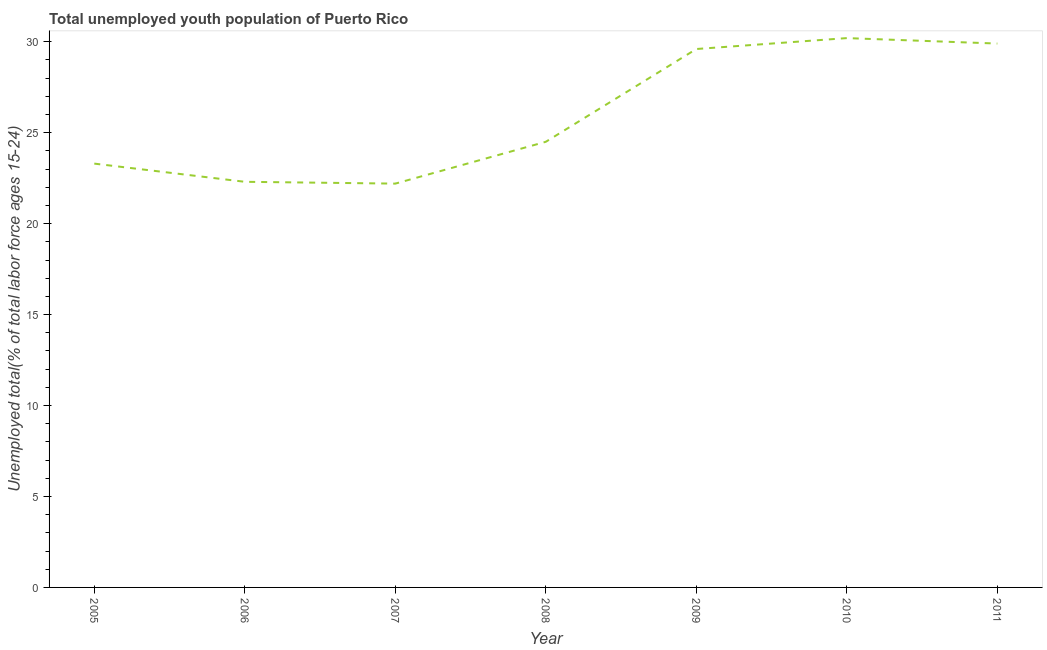What is the unemployed youth in 2005?
Give a very brief answer. 23.3. Across all years, what is the maximum unemployed youth?
Your answer should be very brief. 30.2. Across all years, what is the minimum unemployed youth?
Keep it short and to the point. 22.2. In which year was the unemployed youth maximum?
Ensure brevity in your answer.  2010. In which year was the unemployed youth minimum?
Ensure brevity in your answer.  2007. What is the sum of the unemployed youth?
Your response must be concise. 182. What is the difference between the unemployed youth in 2005 and 2010?
Give a very brief answer. -6.9. What is the average unemployed youth per year?
Make the answer very short. 26. What is the median unemployed youth?
Provide a succinct answer. 24.5. Do a majority of the years between 2009 and 2008 (inclusive) have unemployed youth greater than 6 %?
Give a very brief answer. No. What is the ratio of the unemployed youth in 2005 to that in 2009?
Ensure brevity in your answer.  0.79. What is the difference between the highest and the second highest unemployed youth?
Your answer should be compact. 0.3. Is the sum of the unemployed youth in 2007 and 2011 greater than the maximum unemployed youth across all years?
Offer a terse response. Yes. In how many years, is the unemployed youth greater than the average unemployed youth taken over all years?
Offer a terse response. 3. Does the unemployed youth monotonically increase over the years?
Offer a terse response. No. How many lines are there?
Your answer should be very brief. 1. What is the difference between two consecutive major ticks on the Y-axis?
Your answer should be very brief. 5. Does the graph contain any zero values?
Provide a short and direct response. No. Does the graph contain grids?
Keep it short and to the point. No. What is the title of the graph?
Offer a very short reply. Total unemployed youth population of Puerto Rico. What is the label or title of the X-axis?
Ensure brevity in your answer.  Year. What is the label or title of the Y-axis?
Provide a short and direct response. Unemployed total(% of total labor force ages 15-24). What is the Unemployed total(% of total labor force ages 15-24) in 2005?
Keep it short and to the point. 23.3. What is the Unemployed total(% of total labor force ages 15-24) in 2006?
Provide a short and direct response. 22.3. What is the Unemployed total(% of total labor force ages 15-24) in 2007?
Keep it short and to the point. 22.2. What is the Unemployed total(% of total labor force ages 15-24) of 2009?
Offer a very short reply. 29.6. What is the Unemployed total(% of total labor force ages 15-24) in 2010?
Offer a terse response. 30.2. What is the Unemployed total(% of total labor force ages 15-24) of 2011?
Your response must be concise. 29.9. What is the difference between the Unemployed total(% of total labor force ages 15-24) in 2005 and 2006?
Your answer should be compact. 1. What is the difference between the Unemployed total(% of total labor force ages 15-24) in 2005 and 2008?
Your answer should be compact. -1.2. What is the difference between the Unemployed total(% of total labor force ages 15-24) in 2006 and 2007?
Provide a succinct answer. 0.1. What is the difference between the Unemployed total(% of total labor force ages 15-24) in 2007 and 2008?
Provide a short and direct response. -2.3. What is the difference between the Unemployed total(% of total labor force ages 15-24) in 2008 and 2009?
Your answer should be very brief. -5.1. What is the difference between the Unemployed total(% of total labor force ages 15-24) in 2008 and 2011?
Ensure brevity in your answer.  -5.4. What is the difference between the Unemployed total(% of total labor force ages 15-24) in 2009 and 2010?
Provide a succinct answer. -0.6. What is the difference between the Unemployed total(% of total labor force ages 15-24) in 2009 and 2011?
Your answer should be very brief. -0.3. What is the difference between the Unemployed total(% of total labor force ages 15-24) in 2010 and 2011?
Provide a succinct answer. 0.3. What is the ratio of the Unemployed total(% of total labor force ages 15-24) in 2005 to that in 2006?
Your response must be concise. 1.04. What is the ratio of the Unemployed total(% of total labor force ages 15-24) in 2005 to that in 2007?
Provide a succinct answer. 1.05. What is the ratio of the Unemployed total(% of total labor force ages 15-24) in 2005 to that in 2008?
Your answer should be very brief. 0.95. What is the ratio of the Unemployed total(% of total labor force ages 15-24) in 2005 to that in 2009?
Keep it short and to the point. 0.79. What is the ratio of the Unemployed total(% of total labor force ages 15-24) in 2005 to that in 2010?
Provide a short and direct response. 0.77. What is the ratio of the Unemployed total(% of total labor force ages 15-24) in 2005 to that in 2011?
Your answer should be very brief. 0.78. What is the ratio of the Unemployed total(% of total labor force ages 15-24) in 2006 to that in 2007?
Make the answer very short. 1. What is the ratio of the Unemployed total(% of total labor force ages 15-24) in 2006 to that in 2008?
Keep it short and to the point. 0.91. What is the ratio of the Unemployed total(% of total labor force ages 15-24) in 2006 to that in 2009?
Keep it short and to the point. 0.75. What is the ratio of the Unemployed total(% of total labor force ages 15-24) in 2006 to that in 2010?
Offer a very short reply. 0.74. What is the ratio of the Unemployed total(% of total labor force ages 15-24) in 2006 to that in 2011?
Your response must be concise. 0.75. What is the ratio of the Unemployed total(% of total labor force ages 15-24) in 2007 to that in 2008?
Your response must be concise. 0.91. What is the ratio of the Unemployed total(% of total labor force ages 15-24) in 2007 to that in 2009?
Offer a very short reply. 0.75. What is the ratio of the Unemployed total(% of total labor force ages 15-24) in 2007 to that in 2010?
Ensure brevity in your answer.  0.73. What is the ratio of the Unemployed total(% of total labor force ages 15-24) in 2007 to that in 2011?
Provide a short and direct response. 0.74. What is the ratio of the Unemployed total(% of total labor force ages 15-24) in 2008 to that in 2009?
Give a very brief answer. 0.83. What is the ratio of the Unemployed total(% of total labor force ages 15-24) in 2008 to that in 2010?
Give a very brief answer. 0.81. What is the ratio of the Unemployed total(% of total labor force ages 15-24) in 2008 to that in 2011?
Ensure brevity in your answer.  0.82. What is the ratio of the Unemployed total(% of total labor force ages 15-24) in 2009 to that in 2010?
Make the answer very short. 0.98. What is the ratio of the Unemployed total(% of total labor force ages 15-24) in 2010 to that in 2011?
Make the answer very short. 1.01. 